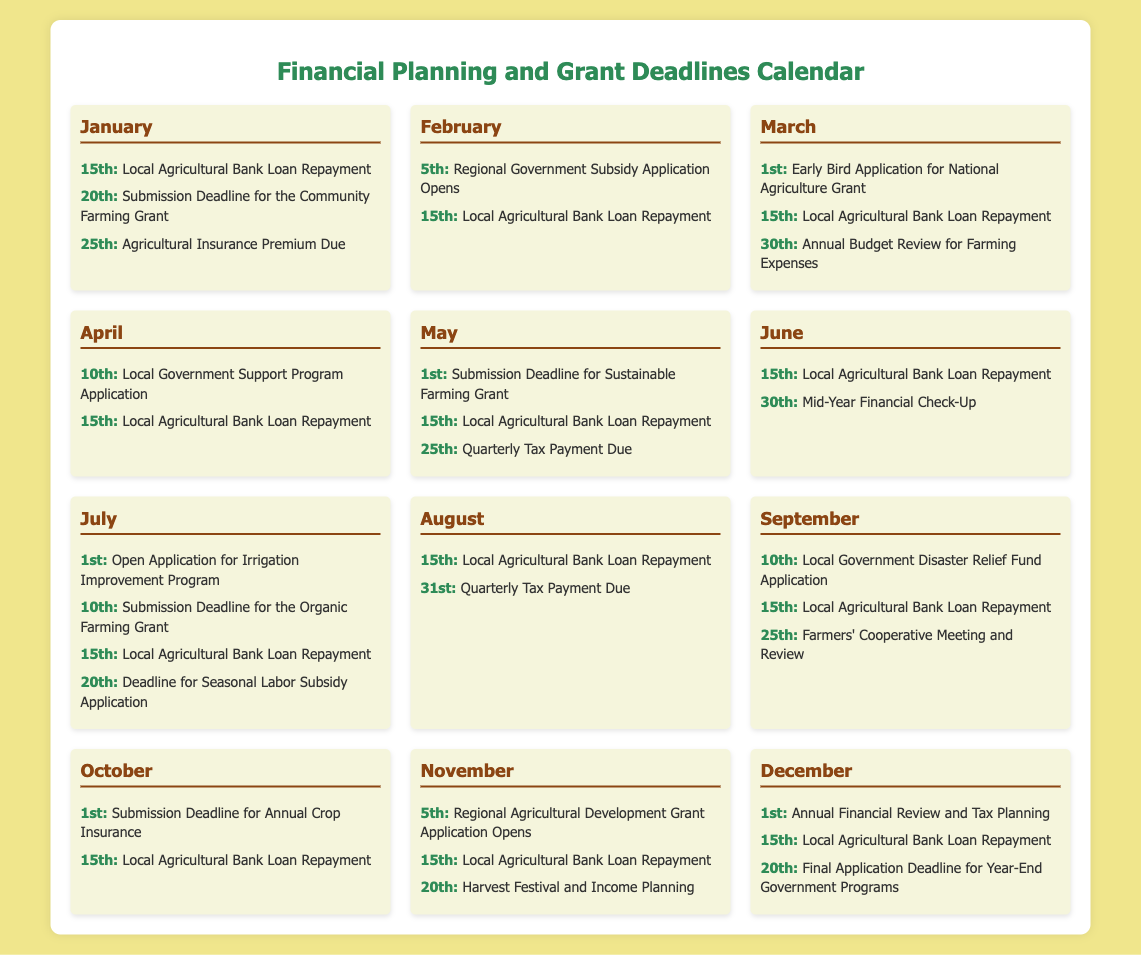What is the submission deadline for the Community Farming Grant? The submission deadline for the Community Farming Grant is on the 20th of January.
Answer: 20th When is the Open Application for the Irrigation Improvement Program? The Open Application for the Irrigation Improvement Program is on the 1st of July.
Answer: 1st How often is the Local Agricultural Bank Loan Repayment due? The Local Agricultural Bank Loan Repayment is due on the 15th of each month.
Answer: 15th What is the date for the Annual Financial Review and Tax Planning? The date for the Annual Financial Review and Tax Planning is on the 1st of December.
Answer: 1st Which month has the final application deadline for year-end government programs? The final application deadline for year-end government programs is in December.
Answer: December What is the total number of grant application deadlines listed in the calendar? The calendar lists a total of four grant application deadlines: two in January, one in May, and one in July.
Answer: Four Which month's activities include a Farmers' Cooperative Meeting and Review? The Farmers' Cooperative Meeting and Review is in September.
Answer: September What is the due date for the Agricultural Insurance Premium? The Agricultural Insurance Premium is due on the 25th of January.
Answer: 25th Which program's application opens in November? The Regional Agricultural Development Grant Application opens in November.
Answer: Regional Agricultural Development Grant 